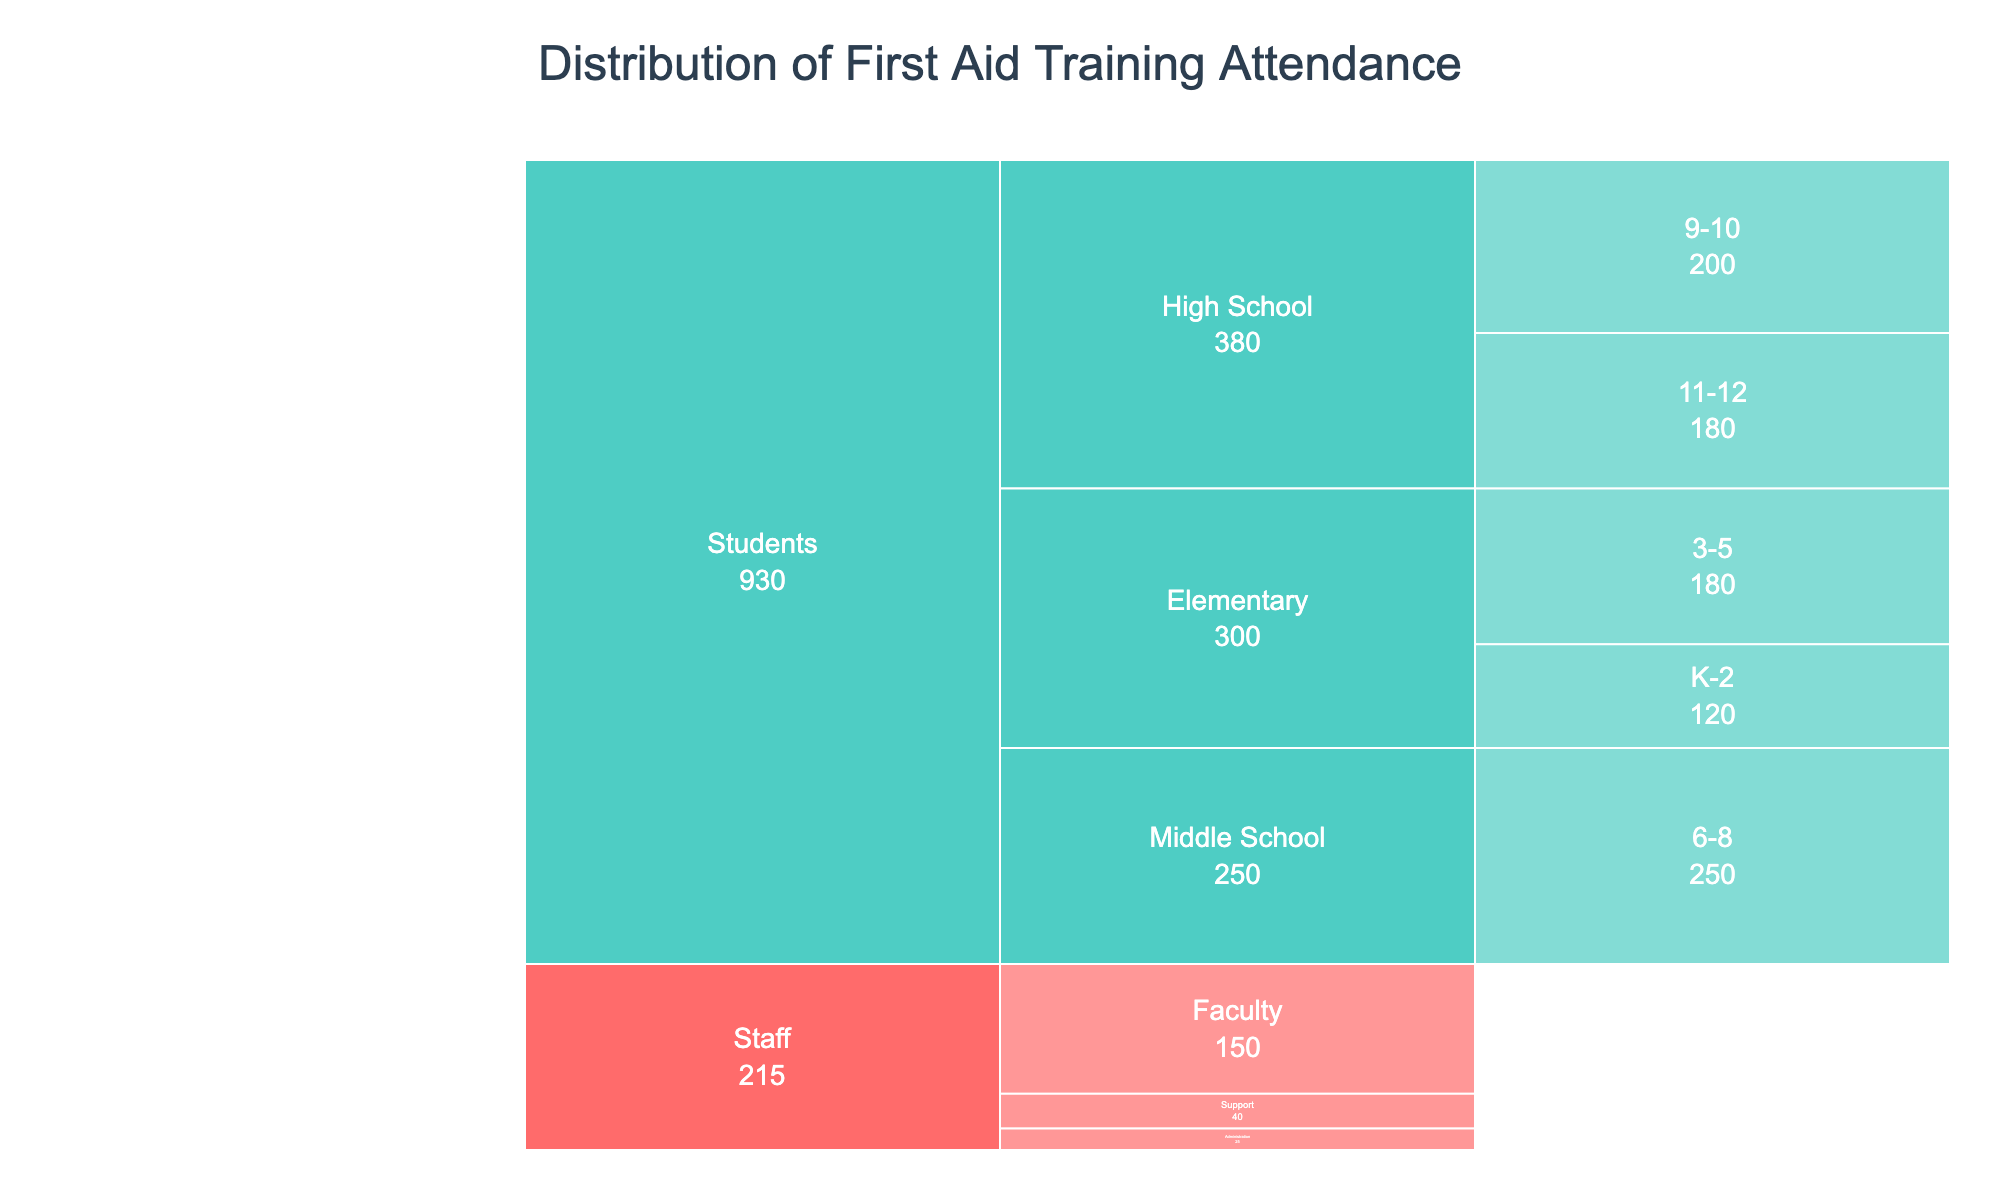What is the title of the figure? The title is prominently displayed at the top of the chart. It is a text element that provides a brief description of what the chart represents.
Answer: Distribution of First Aid Training Attendance How many categories are represented in the chart? There are two main categories shown in the chart, represented by distinct colors. These categories are labeled in the legend.
Answer: Two (Staff and Students) Which department has the highest number of staff attendees? To find the department with the highest number of staff attendees, look at the branches under the "Staff" category and compare their values.
Answer: Faculty What is the total number of student attendees in the elementary grades? Sum the number of attendees from the grades K-2 and 3-5 under the Elementary department within the Students category.
Answer: 120 (K-2) + 180 (3-5) = 300 How does the attendance of middle school students compare to that of high school students (grades 9-10)? Compare the values listed for Middle School students and High School students in grades 9-10.
Answer: Middle School has more attendees (250 vs. 200) Which grade level has the least student attendees within the High School department? Among the grade levels within the High School department, compare the values for each grade level to determine which has the least.
Answer: Grades 11-12 What is the combined total of all staff attendees? Sum the number of attendees under all departments represented within the Staff category.
Answer: 150 (Faculty) + 25 (Administration) + 40 (Support) = 215 Compare the number of attendees in the Support department to the number of attendees in Elementary (K-2). Which is greater? Compare the value for the Support department under Staff with the value for Elementary (K-2) under Students.
Answer: Elementary (K-2) has more attendees (120 vs. 40) Which category has more attendees, Staff or Students? Sum the total attendees for each category by adding up the values for staff and students separately, then compare.
Answer: Students In which grade level within Elementary is the training attendance higher? Compare the values for the two grade levels within the Elementary department (K-2 and 3-5) in the Students category.
Answer: Grades 3-5 